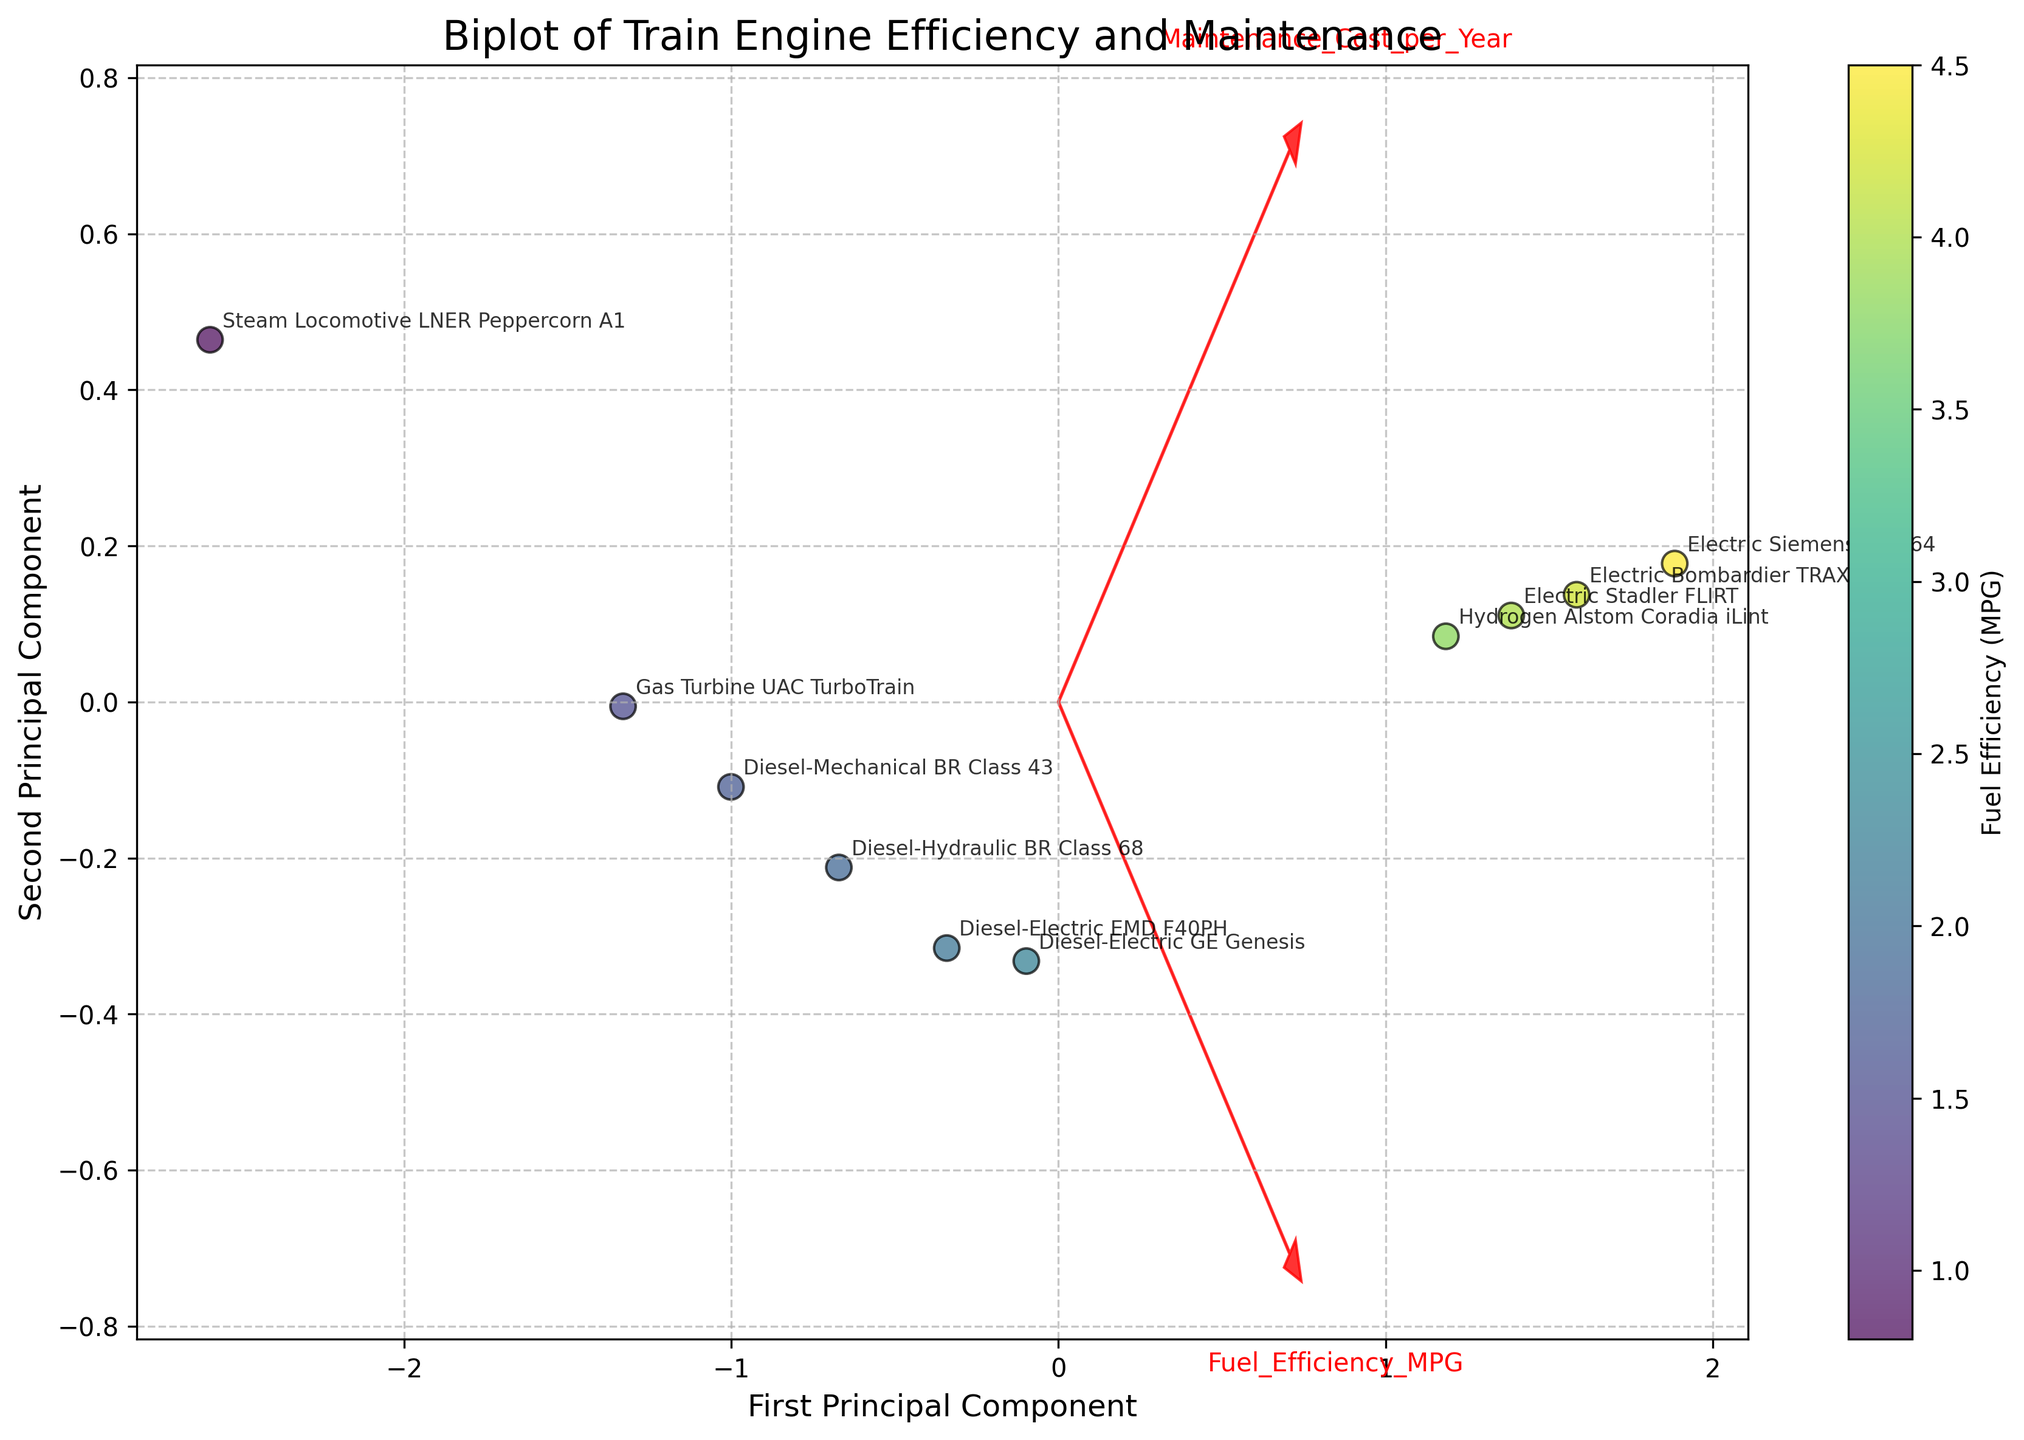What is the title of the plot? The title is located at the top of the figure. It is an important identifier for the information being presented.
Answer: Biplot of Train Engine Efficiency and Maintenance How many train engines are analyzed in the plot? Count the number of data points or annotations on the scatter plot. Each represents a different train engine.
Answer: 10 Which train engine has the lowest fuel efficiency (MPG)? Locate the color corresponding to the lowest value on the color bar scale, identify the data point with that color, and check the annotation.
Answer: Steam Locomotive LNER Peppercorn A1 Which engine type has the highest maintenance cost per year? Look for the data point with the highest position on the vertical axis (Maintenance Cost per Year) and check the annotation.
Answer: Steam Locomotive LNER Peppercorn A1 What principal components are shown on the X and Y axes? The axes labels provide this information. The X-axis represents one principal component, and the Y-axis represents another.
Answer: First Principal Component (X-axis) and Second Principal Component (Y-axis) What is the relationship between fuel efficiency and maintenance cost according to the direction of the arrows? Evaluate the orientation of the feature vectors (arrows). If they point in generally similar or opposite directions, it shows a relationship between the two factors.
Answer: Fuel Efficiency and Maintenance Cost are inversely related Which electric engine has the best balance of fuel efficiency and maintenance cost? Identify electric engines from the annotations, then compare their positions in terms of both principal components to find the one closest to the origin.
Answer: Electric Siemens ACS-64 How does the Diesel-Hydraulic BR Class 68 compare in efficiency and cost to the Diesel-Mechanical BR Class 43? Find the positions of these two engines' data points on the plot, then analyze their relative distances along the principal components.
Answer: The Diesel-Hydraulic BR Class 68 has lower fuel efficiency and lower maintenance costs than the Diesel-Mechanical BR Class 43 Which feature vector seems to have more influence along the first principal component? Examine the length and direction of the arrows representing the feature vectors corresponding to each factor along the first principal component.
Answer: Maintenance Cost per Year 